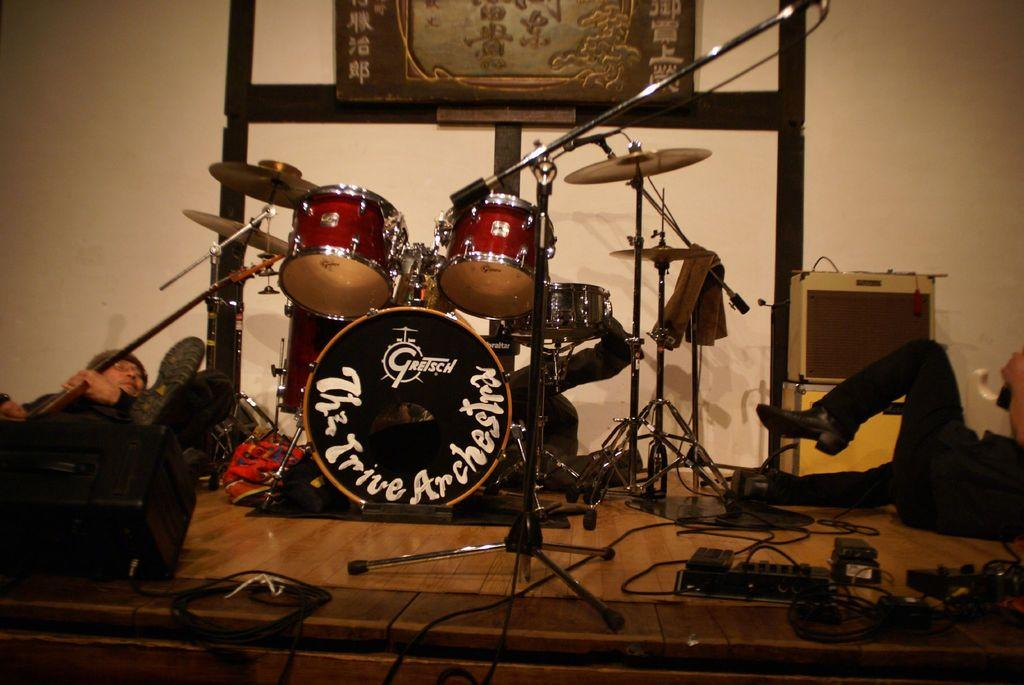What are the people in the image doing? The people in the image are lying on the stage. What is the main feature in the middle of the stage? There is a big band in the middle of the stage. What can be seen in the background of the image? There is a wall in the background of the image. What type of blade can be seen in the image? There is no blade present in the image. Can you hear the people in the image crying? The image is silent, so we cannot hear any crying. 